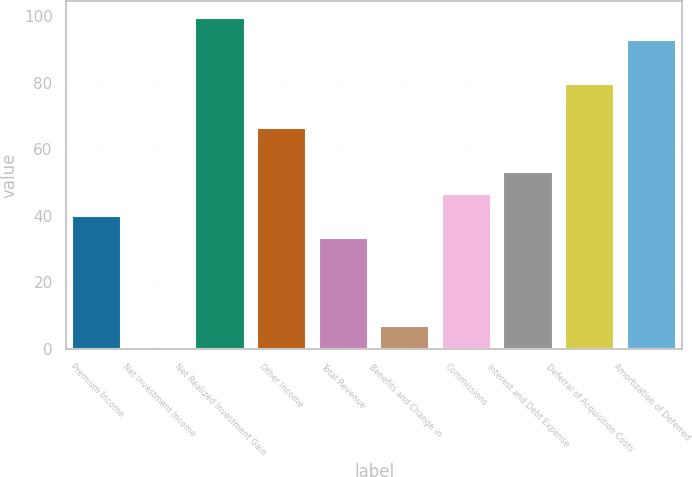Convert chart. <chart><loc_0><loc_0><loc_500><loc_500><bar_chart><fcel>Premium Income<fcel>Net Investment Income<fcel>Net Realized Investment Gain<fcel>Other Income<fcel>Total Revenue<fcel>Benefits and Change in<fcel>Commissions<fcel>Interest and Debt Expense<fcel>Deferral of Acquisition Costs<fcel>Amortization of Deferred<nl><fcel>40.02<fcel>0.3<fcel>99.6<fcel>66.5<fcel>33.4<fcel>6.92<fcel>46.64<fcel>53.26<fcel>79.74<fcel>92.98<nl></chart> 